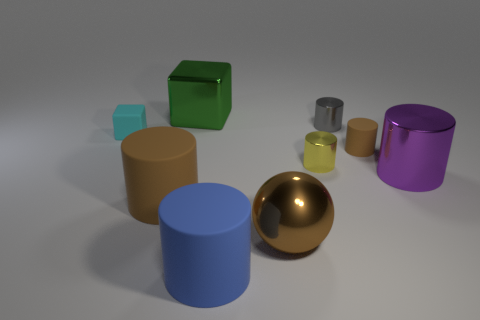Subtract 3 cylinders. How many cylinders are left? 3 Subtract all blue cylinders. How many cylinders are left? 5 Subtract all purple metal cylinders. How many cylinders are left? 5 Subtract all yellow cylinders. Subtract all cyan balls. How many cylinders are left? 5 Add 1 tiny blue matte blocks. How many objects exist? 10 Subtract all cylinders. How many objects are left? 3 Add 3 cyan things. How many cyan things exist? 4 Subtract 0 green cylinders. How many objects are left? 9 Subtract all small cyan matte cylinders. Subtract all small yellow objects. How many objects are left? 8 Add 9 brown balls. How many brown balls are left? 10 